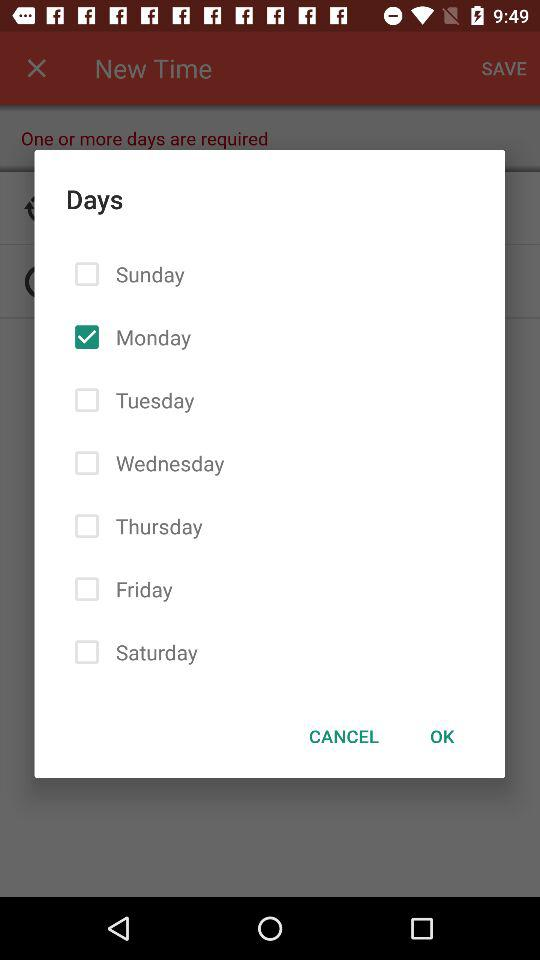Which day is selected? The selected day is Monday. 